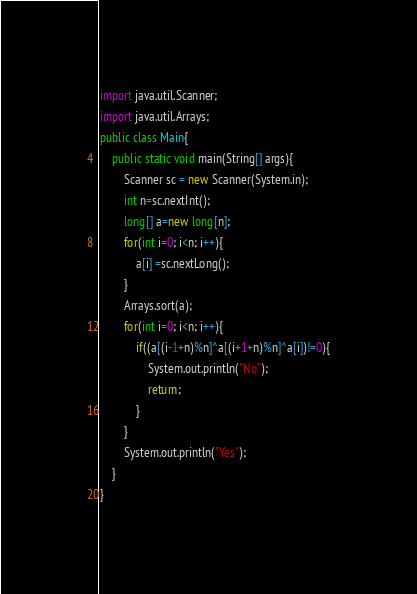<code> <loc_0><loc_0><loc_500><loc_500><_Java_>import java.util.Scanner;
import java.util.Arrays;
public class Main{
	public static void main(String[] args){
		Scanner sc = new Scanner(System.in);
		int n=sc.nextInt();
		long[] a=new long[n];
		for(int i=0; i<n; i++){
			a[i] =sc.nextLong();
		}
		Arrays.sort(a);
		for(int i=0; i<n; i++){
			if((a[(i-1+n)%n]^a[(i+1+n)%n]^a[i])!=0){
				System.out.println("No");
				return;
			}
		}
		System.out.println("Yes");
	}
}


</code> 